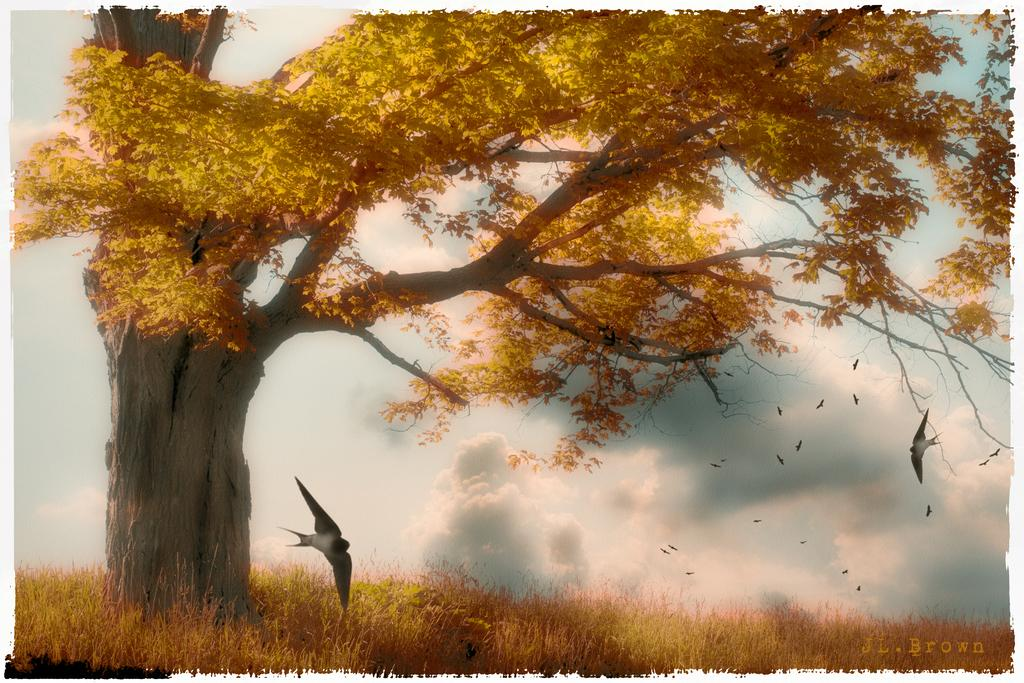What type of vegetation is present in the image? There is grass in the image. What other natural element can be seen in the image? There is a tree in the image. What animals are present in the image? There are flocks of birds in the image. What part of the natural environment is visible in the image? The sky is visible in the image. Can you describe the appearance of the image? The image appears to be an edited photo. What type of music can be heard playing in the background of the image? There is no music present in the image, as it is a still photo. How many passengers are visible in the image? There are no passengers visible in the image, as it features natural elements and animals. 